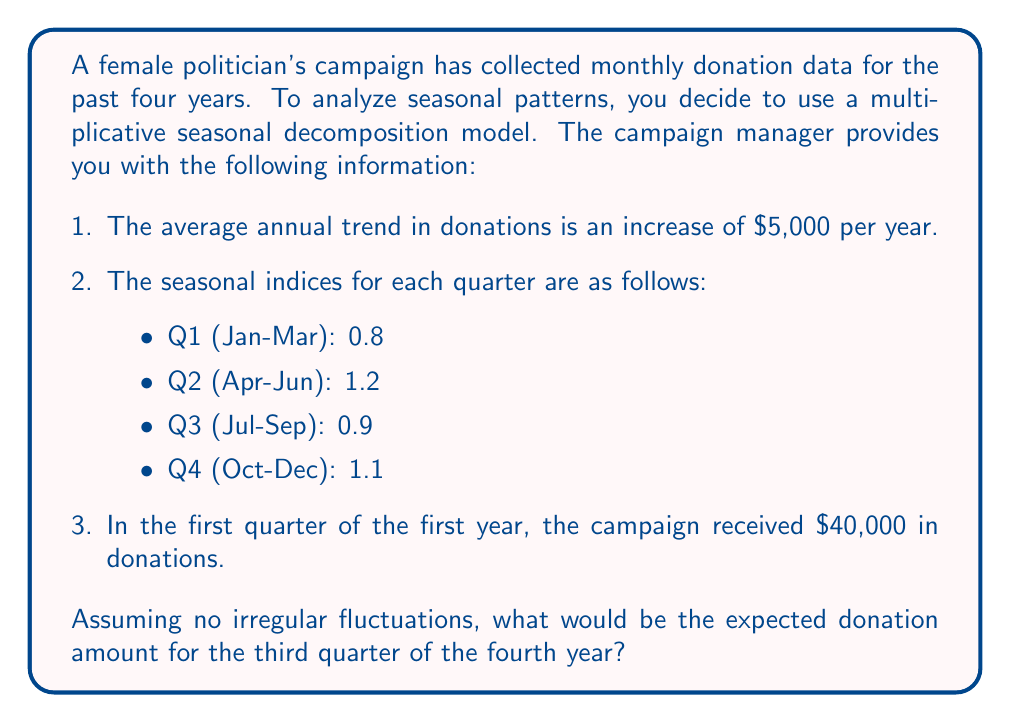Teach me how to tackle this problem. To solve this problem, we'll use the multiplicative seasonal decomposition model:

$$ Y_t = T_t \times S_t \times I_t $$

Where:
$Y_t$ is the observed value
$T_t$ is the trend component
$S_t$ is the seasonal component
$I_t$ is the irregular component (assumed to be 1 in this case)

Let's break down the solution step-by-step:

1. Calculate the trend component for Q3 of Year 4:
   - Initial value: $40,000
   - Annual increase: $5,000
   - Time passed: 3.5 years (as Q3 is mid-year)
   
   $T_t = 40,000 + (5,000 \times 3.5) = 57,500$

2. Identify the seasonal index for Q3:
   $S_t = 0.9$

3. Apply the multiplicative model:
   $Y_t = T_t \times S_t \times I_t$
   $Y_t = 57,500 \times 0.9 \times 1$

4. Calculate the final result:
   $Y_t = 51,750$

Therefore, the expected donation amount for the third quarter of the fourth year would be $51,750.
Answer: $51,750 